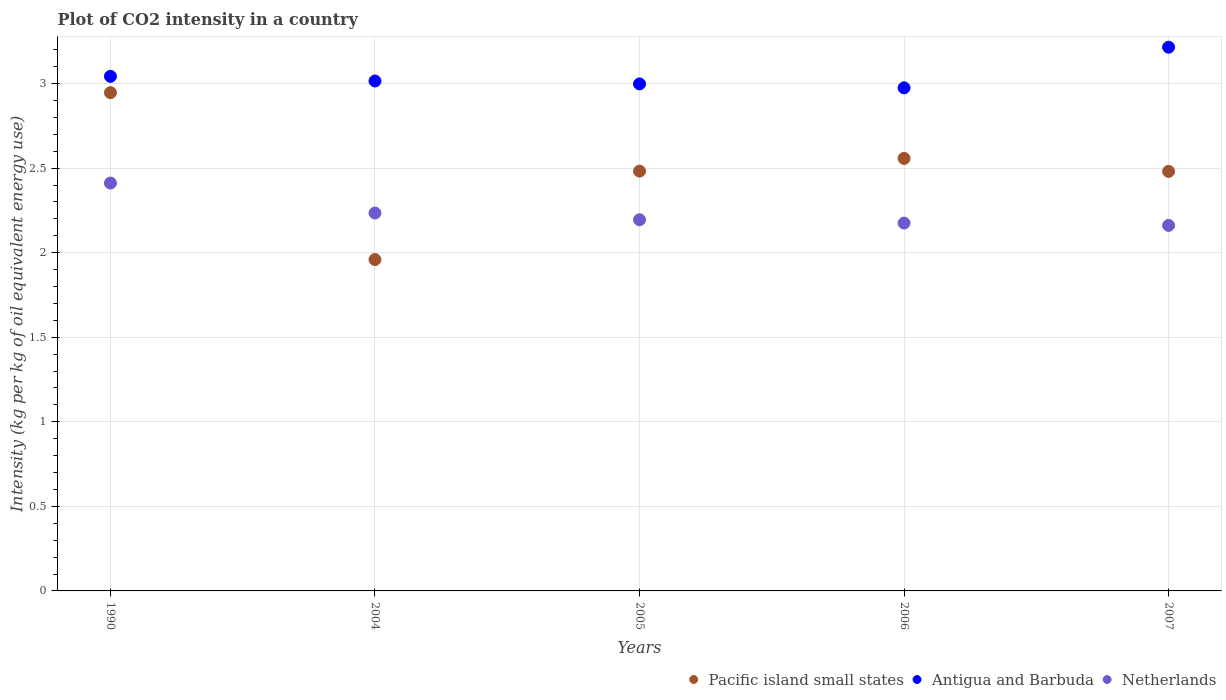How many different coloured dotlines are there?
Keep it short and to the point. 3. What is the CO2 intensity in in Netherlands in 2004?
Your answer should be very brief. 2.23. Across all years, what is the maximum CO2 intensity in in Netherlands?
Your response must be concise. 2.41. Across all years, what is the minimum CO2 intensity in in Netherlands?
Offer a very short reply. 2.16. In which year was the CO2 intensity in in Netherlands maximum?
Make the answer very short. 1990. What is the total CO2 intensity in in Antigua and Barbuda in the graph?
Offer a terse response. 15.25. What is the difference between the CO2 intensity in in Netherlands in 2004 and that in 2005?
Provide a short and direct response. 0.04. What is the difference between the CO2 intensity in in Antigua and Barbuda in 2004 and the CO2 intensity in in Pacific island small states in 2007?
Ensure brevity in your answer.  0.53. What is the average CO2 intensity in in Antigua and Barbuda per year?
Offer a terse response. 3.05. In the year 1990, what is the difference between the CO2 intensity in in Antigua and Barbuda and CO2 intensity in in Netherlands?
Your response must be concise. 0.63. In how many years, is the CO2 intensity in in Antigua and Barbuda greater than 1.9 kg?
Make the answer very short. 5. What is the ratio of the CO2 intensity in in Antigua and Barbuda in 2004 to that in 2006?
Provide a short and direct response. 1.01. What is the difference between the highest and the second highest CO2 intensity in in Netherlands?
Provide a short and direct response. 0.18. What is the difference between the highest and the lowest CO2 intensity in in Pacific island small states?
Ensure brevity in your answer.  0.99. In how many years, is the CO2 intensity in in Netherlands greater than the average CO2 intensity in in Netherlands taken over all years?
Keep it short and to the point. 1. Is the sum of the CO2 intensity in in Netherlands in 2004 and 2005 greater than the maximum CO2 intensity in in Antigua and Barbuda across all years?
Offer a terse response. Yes. Is it the case that in every year, the sum of the CO2 intensity in in Antigua and Barbuda and CO2 intensity in in Netherlands  is greater than the CO2 intensity in in Pacific island small states?
Give a very brief answer. Yes. Does the CO2 intensity in in Antigua and Barbuda monotonically increase over the years?
Your response must be concise. No. Is the CO2 intensity in in Netherlands strictly greater than the CO2 intensity in in Antigua and Barbuda over the years?
Keep it short and to the point. No. Is the CO2 intensity in in Netherlands strictly less than the CO2 intensity in in Antigua and Barbuda over the years?
Keep it short and to the point. Yes. Does the graph contain any zero values?
Offer a very short reply. No. Where does the legend appear in the graph?
Ensure brevity in your answer.  Bottom right. What is the title of the graph?
Offer a terse response. Plot of CO2 intensity in a country. What is the label or title of the Y-axis?
Keep it short and to the point. Intensity (kg per kg of oil equivalent energy use). What is the Intensity (kg per kg of oil equivalent energy use) of Pacific island small states in 1990?
Your answer should be very brief. 2.95. What is the Intensity (kg per kg of oil equivalent energy use) of Antigua and Barbuda in 1990?
Your answer should be compact. 3.04. What is the Intensity (kg per kg of oil equivalent energy use) of Netherlands in 1990?
Offer a very short reply. 2.41. What is the Intensity (kg per kg of oil equivalent energy use) in Pacific island small states in 2004?
Keep it short and to the point. 1.96. What is the Intensity (kg per kg of oil equivalent energy use) of Antigua and Barbuda in 2004?
Offer a terse response. 3.02. What is the Intensity (kg per kg of oil equivalent energy use) of Netherlands in 2004?
Offer a terse response. 2.23. What is the Intensity (kg per kg of oil equivalent energy use) of Pacific island small states in 2005?
Give a very brief answer. 2.48. What is the Intensity (kg per kg of oil equivalent energy use) in Antigua and Barbuda in 2005?
Ensure brevity in your answer.  3. What is the Intensity (kg per kg of oil equivalent energy use) in Netherlands in 2005?
Provide a short and direct response. 2.19. What is the Intensity (kg per kg of oil equivalent energy use) of Pacific island small states in 2006?
Make the answer very short. 2.56. What is the Intensity (kg per kg of oil equivalent energy use) of Antigua and Barbuda in 2006?
Give a very brief answer. 2.97. What is the Intensity (kg per kg of oil equivalent energy use) of Netherlands in 2006?
Offer a very short reply. 2.18. What is the Intensity (kg per kg of oil equivalent energy use) in Pacific island small states in 2007?
Make the answer very short. 2.48. What is the Intensity (kg per kg of oil equivalent energy use) in Antigua and Barbuda in 2007?
Give a very brief answer. 3.21. What is the Intensity (kg per kg of oil equivalent energy use) in Netherlands in 2007?
Provide a succinct answer. 2.16. Across all years, what is the maximum Intensity (kg per kg of oil equivalent energy use) in Pacific island small states?
Your answer should be very brief. 2.95. Across all years, what is the maximum Intensity (kg per kg of oil equivalent energy use) of Antigua and Barbuda?
Your answer should be very brief. 3.21. Across all years, what is the maximum Intensity (kg per kg of oil equivalent energy use) in Netherlands?
Offer a very short reply. 2.41. Across all years, what is the minimum Intensity (kg per kg of oil equivalent energy use) in Pacific island small states?
Make the answer very short. 1.96. Across all years, what is the minimum Intensity (kg per kg of oil equivalent energy use) in Antigua and Barbuda?
Make the answer very short. 2.97. Across all years, what is the minimum Intensity (kg per kg of oil equivalent energy use) in Netherlands?
Your answer should be very brief. 2.16. What is the total Intensity (kg per kg of oil equivalent energy use) of Pacific island small states in the graph?
Offer a very short reply. 12.43. What is the total Intensity (kg per kg of oil equivalent energy use) in Antigua and Barbuda in the graph?
Give a very brief answer. 15.25. What is the total Intensity (kg per kg of oil equivalent energy use) of Netherlands in the graph?
Your answer should be very brief. 11.18. What is the difference between the Intensity (kg per kg of oil equivalent energy use) of Pacific island small states in 1990 and that in 2004?
Your answer should be compact. 0.99. What is the difference between the Intensity (kg per kg of oil equivalent energy use) in Antigua and Barbuda in 1990 and that in 2004?
Ensure brevity in your answer.  0.03. What is the difference between the Intensity (kg per kg of oil equivalent energy use) in Netherlands in 1990 and that in 2004?
Provide a succinct answer. 0.18. What is the difference between the Intensity (kg per kg of oil equivalent energy use) of Pacific island small states in 1990 and that in 2005?
Provide a succinct answer. 0.46. What is the difference between the Intensity (kg per kg of oil equivalent energy use) of Antigua and Barbuda in 1990 and that in 2005?
Ensure brevity in your answer.  0.04. What is the difference between the Intensity (kg per kg of oil equivalent energy use) in Netherlands in 1990 and that in 2005?
Ensure brevity in your answer.  0.22. What is the difference between the Intensity (kg per kg of oil equivalent energy use) in Pacific island small states in 1990 and that in 2006?
Provide a short and direct response. 0.39. What is the difference between the Intensity (kg per kg of oil equivalent energy use) of Antigua and Barbuda in 1990 and that in 2006?
Ensure brevity in your answer.  0.07. What is the difference between the Intensity (kg per kg of oil equivalent energy use) in Netherlands in 1990 and that in 2006?
Provide a succinct answer. 0.24. What is the difference between the Intensity (kg per kg of oil equivalent energy use) of Pacific island small states in 1990 and that in 2007?
Provide a succinct answer. 0.47. What is the difference between the Intensity (kg per kg of oil equivalent energy use) of Antigua and Barbuda in 1990 and that in 2007?
Keep it short and to the point. -0.17. What is the difference between the Intensity (kg per kg of oil equivalent energy use) of Netherlands in 1990 and that in 2007?
Provide a succinct answer. 0.25. What is the difference between the Intensity (kg per kg of oil equivalent energy use) of Pacific island small states in 2004 and that in 2005?
Your response must be concise. -0.52. What is the difference between the Intensity (kg per kg of oil equivalent energy use) in Antigua and Barbuda in 2004 and that in 2005?
Your answer should be very brief. 0.02. What is the difference between the Intensity (kg per kg of oil equivalent energy use) in Netherlands in 2004 and that in 2005?
Keep it short and to the point. 0.04. What is the difference between the Intensity (kg per kg of oil equivalent energy use) in Pacific island small states in 2004 and that in 2006?
Your response must be concise. -0.6. What is the difference between the Intensity (kg per kg of oil equivalent energy use) of Antigua and Barbuda in 2004 and that in 2006?
Offer a very short reply. 0.04. What is the difference between the Intensity (kg per kg of oil equivalent energy use) in Netherlands in 2004 and that in 2006?
Provide a succinct answer. 0.06. What is the difference between the Intensity (kg per kg of oil equivalent energy use) of Pacific island small states in 2004 and that in 2007?
Make the answer very short. -0.52. What is the difference between the Intensity (kg per kg of oil equivalent energy use) in Antigua and Barbuda in 2004 and that in 2007?
Make the answer very short. -0.2. What is the difference between the Intensity (kg per kg of oil equivalent energy use) of Netherlands in 2004 and that in 2007?
Give a very brief answer. 0.07. What is the difference between the Intensity (kg per kg of oil equivalent energy use) of Pacific island small states in 2005 and that in 2006?
Keep it short and to the point. -0.08. What is the difference between the Intensity (kg per kg of oil equivalent energy use) in Antigua and Barbuda in 2005 and that in 2006?
Give a very brief answer. 0.02. What is the difference between the Intensity (kg per kg of oil equivalent energy use) in Netherlands in 2005 and that in 2006?
Keep it short and to the point. 0.02. What is the difference between the Intensity (kg per kg of oil equivalent energy use) of Pacific island small states in 2005 and that in 2007?
Offer a terse response. 0. What is the difference between the Intensity (kg per kg of oil equivalent energy use) in Antigua and Barbuda in 2005 and that in 2007?
Provide a short and direct response. -0.22. What is the difference between the Intensity (kg per kg of oil equivalent energy use) in Netherlands in 2005 and that in 2007?
Keep it short and to the point. 0.03. What is the difference between the Intensity (kg per kg of oil equivalent energy use) of Pacific island small states in 2006 and that in 2007?
Offer a terse response. 0.08. What is the difference between the Intensity (kg per kg of oil equivalent energy use) of Antigua and Barbuda in 2006 and that in 2007?
Your answer should be very brief. -0.24. What is the difference between the Intensity (kg per kg of oil equivalent energy use) in Netherlands in 2006 and that in 2007?
Your response must be concise. 0.01. What is the difference between the Intensity (kg per kg of oil equivalent energy use) in Pacific island small states in 1990 and the Intensity (kg per kg of oil equivalent energy use) in Antigua and Barbuda in 2004?
Make the answer very short. -0.07. What is the difference between the Intensity (kg per kg of oil equivalent energy use) in Pacific island small states in 1990 and the Intensity (kg per kg of oil equivalent energy use) in Netherlands in 2004?
Provide a succinct answer. 0.71. What is the difference between the Intensity (kg per kg of oil equivalent energy use) in Antigua and Barbuda in 1990 and the Intensity (kg per kg of oil equivalent energy use) in Netherlands in 2004?
Provide a succinct answer. 0.81. What is the difference between the Intensity (kg per kg of oil equivalent energy use) in Pacific island small states in 1990 and the Intensity (kg per kg of oil equivalent energy use) in Antigua and Barbuda in 2005?
Provide a succinct answer. -0.05. What is the difference between the Intensity (kg per kg of oil equivalent energy use) in Pacific island small states in 1990 and the Intensity (kg per kg of oil equivalent energy use) in Netherlands in 2005?
Make the answer very short. 0.75. What is the difference between the Intensity (kg per kg of oil equivalent energy use) in Antigua and Barbuda in 1990 and the Intensity (kg per kg of oil equivalent energy use) in Netherlands in 2005?
Your response must be concise. 0.85. What is the difference between the Intensity (kg per kg of oil equivalent energy use) in Pacific island small states in 1990 and the Intensity (kg per kg of oil equivalent energy use) in Antigua and Barbuda in 2006?
Make the answer very short. -0.03. What is the difference between the Intensity (kg per kg of oil equivalent energy use) in Pacific island small states in 1990 and the Intensity (kg per kg of oil equivalent energy use) in Netherlands in 2006?
Your response must be concise. 0.77. What is the difference between the Intensity (kg per kg of oil equivalent energy use) of Antigua and Barbuda in 1990 and the Intensity (kg per kg of oil equivalent energy use) of Netherlands in 2006?
Your answer should be compact. 0.87. What is the difference between the Intensity (kg per kg of oil equivalent energy use) in Pacific island small states in 1990 and the Intensity (kg per kg of oil equivalent energy use) in Antigua and Barbuda in 2007?
Provide a short and direct response. -0.27. What is the difference between the Intensity (kg per kg of oil equivalent energy use) of Pacific island small states in 1990 and the Intensity (kg per kg of oil equivalent energy use) of Netherlands in 2007?
Ensure brevity in your answer.  0.78. What is the difference between the Intensity (kg per kg of oil equivalent energy use) of Antigua and Barbuda in 1990 and the Intensity (kg per kg of oil equivalent energy use) of Netherlands in 2007?
Your answer should be compact. 0.88. What is the difference between the Intensity (kg per kg of oil equivalent energy use) in Pacific island small states in 2004 and the Intensity (kg per kg of oil equivalent energy use) in Antigua and Barbuda in 2005?
Offer a terse response. -1.04. What is the difference between the Intensity (kg per kg of oil equivalent energy use) in Pacific island small states in 2004 and the Intensity (kg per kg of oil equivalent energy use) in Netherlands in 2005?
Ensure brevity in your answer.  -0.24. What is the difference between the Intensity (kg per kg of oil equivalent energy use) of Antigua and Barbuda in 2004 and the Intensity (kg per kg of oil equivalent energy use) of Netherlands in 2005?
Your answer should be compact. 0.82. What is the difference between the Intensity (kg per kg of oil equivalent energy use) in Pacific island small states in 2004 and the Intensity (kg per kg of oil equivalent energy use) in Antigua and Barbuda in 2006?
Make the answer very short. -1.02. What is the difference between the Intensity (kg per kg of oil equivalent energy use) of Pacific island small states in 2004 and the Intensity (kg per kg of oil equivalent energy use) of Netherlands in 2006?
Keep it short and to the point. -0.22. What is the difference between the Intensity (kg per kg of oil equivalent energy use) of Antigua and Barbuda in 2004 and the Intensity (kg per kg of oil equivalent energy use) of Netherlands in 2006?
Offer a very short reply. 0.84. What is the difference between the Intensity (kg per kg of oil equivalent energy use) of Pacific island small states in 2004 and the Intensity (kg per kg of oil equivalent energy use) of Antigua and Barbuda in 2007?
Your answer should be very brief. -1.26. What is the difference between the Intensity (kg per kg of oil equivalent energy use) of Pacific island small states in 2004 and the Intensity (kg per kg of oil equivalent energy use) of Netherlands in 2007?
Offer a terse response. -0.2. What is the difference between the Intensity (kg per kg of oil equivalent energy use) of Antigua and Barbuda in 2004 and the Intensity (kg per kg of oil equivalent energy use) of Netherlands in 2007?
Your answer should be compact. 0.85. What is the difference between the Intensity (kg per kg of oil equivalent energy use) of Pacific island small states in 2005 and the Intensity (kg per kg of oil equivalent energy use) of Antigua and Barbuda in 2006?
Keep it short and to the point. -0.49. What is the difference between the Intensity (kg per kg of oil equivalent energy use) in Pacific island small states in 2005 and the Intensity (kg per kg of oil equivalent energy use) in Netherlands in 2006?
Your answer should be compact. 0.31. What is the difference between the Intensity (kg per kg of oil equivalent energy use) of Antigua and Barbuda in 2005 and the Intensity (kg per kg of oil equivalent energy use) of Netherlands in 2006?
Give a very brief answer. 0.82. What is the difference between the Intensity (kg per kg of oil equivalent energy use) in Pacific island small states in 2005 and the Intensity (kg per kg of oil equivalent energy use) in Antigua and Barbuda in 2007?
Your answer should be very brief. -0.73. What is the difference between the Intensity (kg per kg of oil equivalent energy use) of Pacific island small states in 2005 and the Intensity (kg per kg of oil equivalent energy use) of Netherlands in 2007?
Offer a terse response. 0.32. What is the difference between the Intensity (kg per kg of oil equivalent energy use) in Antigua and Barbuda in 2005 and the Intensity (kg per kg of oil equivalent energy use) in Netherlands in 2007?
Provide a succinct answer. 0.84. What is the difference between the Intensity (kg per kg of oil equivalent energy use) in Pacific island small states in 2006 and the Intensity (kg per kg of oil equivalent energy use) in Antigua and Barbuda in 2007?
Your answer should be compact. -0.66. What is the difference between the Intensity (kg per kg of oil equivalent energy use) of Pacific island small states in 2006 and the Intensity (kg per kg of oil equivalent energy use) of Netherlands in 2007?
Provide a short and direct response. 0.4. What is the difference between the Intensity (kg per kg of oil equivalent energy use) in Antigua and Barbuda in 2006 and the Intensity (kg per kg of oil equivalent energy use) in Netherlands in 2007?
Provide a succinct answer. 0.81. What is the average Intensity (kg per kg of oil equivalent energy use) of Pacific island small states per year?
Your response must be concise. 2.48. What is the average Intensity (kg per kg of oil equivalent energy use) of Antigua and Barbuda per year?
Give a very brief answer. 3.05. What is the average Intensity (kg per kg of oil equivalent energy use) in Netherlands per year?
Make the answer very short. 2.24. In the year 1990, what is the difference between the Intensity (kg per kg of oil equivalent energy use) in Pacific island small states and Intensity (kg per kg of oil equivalent energy use) in Antigua and Barbuda?
Provide a succinct answer. -0.1. In the year 1990, what is the difference between the Intensity (kg per kg of oil equivalent energy use) in Pacific island small states and Intensity (kg per kg of oil equivalent energy use) in Netherlands?
Make the answer very short. 0.53. In the year 1990, what is the difference between the Intensity (kg per kg of oil equivalent energy use) of Antigua and Barbuda and Intensity (kg per kg of oil equivalent energy use) of Netherlands?
Provide a succinct answer. 0.63. In the year 2004, what is the difference between the Intensity (kg per kg of oil equivalent energy use) in Pacific island small states and Intensity (kg per kg of oil equivalent energy use) in Antigua and Barbuda?
Keep it short and to the point. -1.06. In the year 2004, what is the difference between the Intensity (kg per kg of oil equivalent energy use) in Pacific island small states and Intensity (kg per kg of oil equivalent energy use) in Netherlands?
Your response must be concise. -0.28. In the year 2004, what is the difference between the Intensity (kg per kg of oil equivalent energy use) of Antigua and Barbuda and Intensity (kg per kg of oil equivalent energy use) of Netherlands?
Give a very brief answer. 0.78. In the year 2005, what is the difference between the Intensity (kg per kg of oil equivalent energy use) of Pacific island small states and Intensity (kg per kg of oil equivalent energy use) of Antigua and Barbuda?
Offer a very short reply. -0.52. In the year 2005, what is the difference between the Intensity (kg per kg of oil equivalent energy use) in Pacific island small states and Intensity (kg per kg of oil equivalent energy use) in Netherlands?
Give a very brief answer. 0.29. In the year 2005, what is the difference between the Intensity (kg per kg of oil equivalent energy use) of Antigua and Barbuda and Intensity (kg per kg of oil equivalent energy use) of Netherlands?
Provide a succinct answer. 0.8. In the year 2006, what is the difference between the Intensity (kg per kg of oil equivalent energy use) of Pacific island small states and Intensity (kg per kg of oil equivalent energy use) of Antigua and Barbuda?
Provide a short and direct response. -0.42. In the year 2006, what is the difference between the Intensity (kg per kg of oil equivalent energy use) in Pacific island small states and Intensity (kg per kg of oil equivalent energy use) in Netherlands?
Make the answer very short. 0.38. In the year 2006, what is the difference between the Intensity (kg per kg of oil equivalent energy use) of Antigua and Barbuda and Intensity (kg per kg of oil equivalent energy use) of Netherlands?
Your answer should be compact. 0.8. In the year 2007, what is the difference between the Intensity (kg per kg of oil equivalent energy use) of Pacific island small states and Intensity (kg per kg of oil equivalent energy use) of Antigua and Barbuda?
Offer a terse response. -0.73. In the year 2007, what is the difference between the Intensity (kg per kg of oil equivalent energy use) of Pacific island small states and Intensity (kg per kg of oil equivalent energy use) of Netherlands?
Offer a very short reply. 0.32. In the year 2007, what is the difference between the Intensity (kg per kg of oil equivalent energy use) of Antigua and Barbuda and Intensity (kg per kg of oil equivalent energy use) of Netherlands?
Ensure brevity in your answer.  1.05. What is the ratio of the Intensity (kg per kg of oil equivalent energy use) of Pacific island small states in 1990 to that in 2004?
Your answer should be compact. 1.5. What is the ratio of the Intensity (kg per kg of oil equivalent energy use) in Antigua and Barbuda in 1990 to that in 2004?
Provide a succinct answer. 1.01. What is the ratio of the Intensity (kg per kg of oil equivalent energy use) of Netherlands in 1990 to that in 2004?
Give a very brief answer. 1.08. What is the ratio of the Intensity (kg per kg of oil equivalent energy use) of Pacific island small states in 1990 to that in 2005?
Give a very brief answer. 1.19. What is the ratio of the Intensity (kg per kg of oil equivalent energy use) of Antigua and Barbuda in 1990 to that in 2005?
Provide a succinct answer. 1.01. What is the ratio of the Intensity (kg per kg of oil equivalent energy use) of Netherlands in 1990 to that in 2005?
Your answer should be very brief. 1.1. What is the ratio of the Intensity (kg per kg of oil equivalent energy use) of Pacific island small states in 1990 to that in 2006?
Offer a very short reply. 1.15. What is the ratio of the Intensity (kg per kg of oil equivalent energy use) in Antigua and Barbuda in 1990 to that in 2006?
Keep it short and to the point. 1.02. What is the ratio of the Intensity (kg per kg of oil equivalent energy use) of Netherlands in 1990 to that in 2006?
Your response must be concise. 1.11. What is the ratio of the Intensity (kg per kg of oil equivalent energy use) in Pacific island small states in 1990 to that in 2007?
Ensure brevity in your answer.  1.19. What is the ratio of the Intensity (kg per kg of oil equivalent energy use) of Antigua and Barbuda in 1990 to that in 2007?
Your response must be concise. 0.95. What is the ratio of the Intensity (kg per kg of oil equivalent energy use) in Netherlands in 1990 to that in 2007?
Keep it short and to the point. 1.12. What is the ratio of the Intensity (kg per kg of oil equivalent energy use) in Pacific island small states in 2004 to that in 2005?
Provide a succinct answer. 0.79. What is the ratio of the Intensity (kg per kg of oil equivalent energy use) in Antigua and Barbuda in 2004 to that in 2005?
Keep it short and to the point. 1.01. What is the ratio of the Intensity (kg per kg of oil equivalent energy use) of Netherlands in 2004 to that in 2005?
Offer a terse response. 1.02. What is the ratio of the Intensity (kg per kg of oil equivalent energy use) of Pacific island small states in 2004 to that in 2006?
Give a very brief answer. 0.77. What is the ratio of the Intensity (kg per kg of oil equivalent energy use) in Antigua and Barbuda in 2004 to that in 2006?
Offer a terse response. 1.01. What is the ratio of the Intensity (kg per kg of oil equivalent energy use) of Netherlands in 2004 to that in 2006?
Your response must be concise. 1.03. What is the ratio of the Intensity (kg per kg of oil equivalent energy use) in Pacific island small states in 2004 to that in 2007?
Provide a short and direct response. 0.79. What is the ratio of the Intensity (kg per kg of oil equivalent energy use) of Antigua and Barbuda in 2004 to that in 2007?
Provide a succinct answer. 0.94. What is the ratio of the Intensity (kg per kg of oil equivalent energy use) of Netherlands in 2004 to that in 2007?
Provide a succinct answer. 1.03. What is the ratio of the Intensity (kg per kg of oil equivalent energy use) of Pacific island small states in 2005 to that in 2006?
Make the answer very short. 0.97. What is the ratio of the Intensity (kg per kg of oil equivalent energy use) in Antigua and Barbuda in 2005 to that in 2006?
Your response must be concise. 1.01. What is the ratio of the Intensity (kg per kg of oil equivalent energy use) of Netherlands in 2005 to that in 2006?
Your response must be concise. 1.01. What is the ratio of the Intensity (kg per kg of oil equivalent energy use) of Pacific island small states in 2005 to that in 2007?
Your answer should be compact. 1. What is the ratio of the Intensity (kg per kg of oil equivalent energy use) of Antigua and Barbuda in 2005 to that in 2007?
Provide a short and direct response. 0.93. What is the ratio of the Intensity (kg per kg of oil equivalent energy use) of Netherlands in 2005 to that in 2007?
Offer a very short reply. 1.02. What is the ratio of the Intensity (kg per kg of oil equivalent energy use) of Pacific island small states in 2006 to that in 2007?
Make the answer very short. 1.03. What is the ratio of the Intensity (kg per kg of oil equivalent energy use) of Antigua and Barbuda in 2006 to that in 2007?
Your response must be concise. 0.93. What is the ratio of the Intensity (kg per kg of oil equivalent energy use) of Netherlands in 2006 to that in 2007?
Offer a very short reply. 1.01. What is the difference between the highest and the second highest Intensity (kg per kg of oil equivalent energy use) of Pacific island small states?
Ensure brevity in your answer.  0.39. What is the difference between the highest and the second highest Intensity (kg per kg of oil equivalent energy use) in Antigua and Barbuda?
Offer a very short reply. 0.17. What is the difference between the highest and the second highest Intensity (kg per kg of oil equivalent energy use) of Netherlands?
Provide a succinct answer. 0.18. What is the difference between the highest and the lowest Intensity (kg per kg of oil equivalent energy use) of Pacific island small states?
Your answer should be compact. 0.99. What is the difference between the highest and the lowest Intensity (kg per kg of oil equivalent energy use) in Antigua and Barbuda?
Give a very brief answer. 0.24. What is the difference between the highest and the lowest Intensity (kg per kg of oil equivalent energy use) of Netherlands?
Keep it short and to the point. 0.25. 